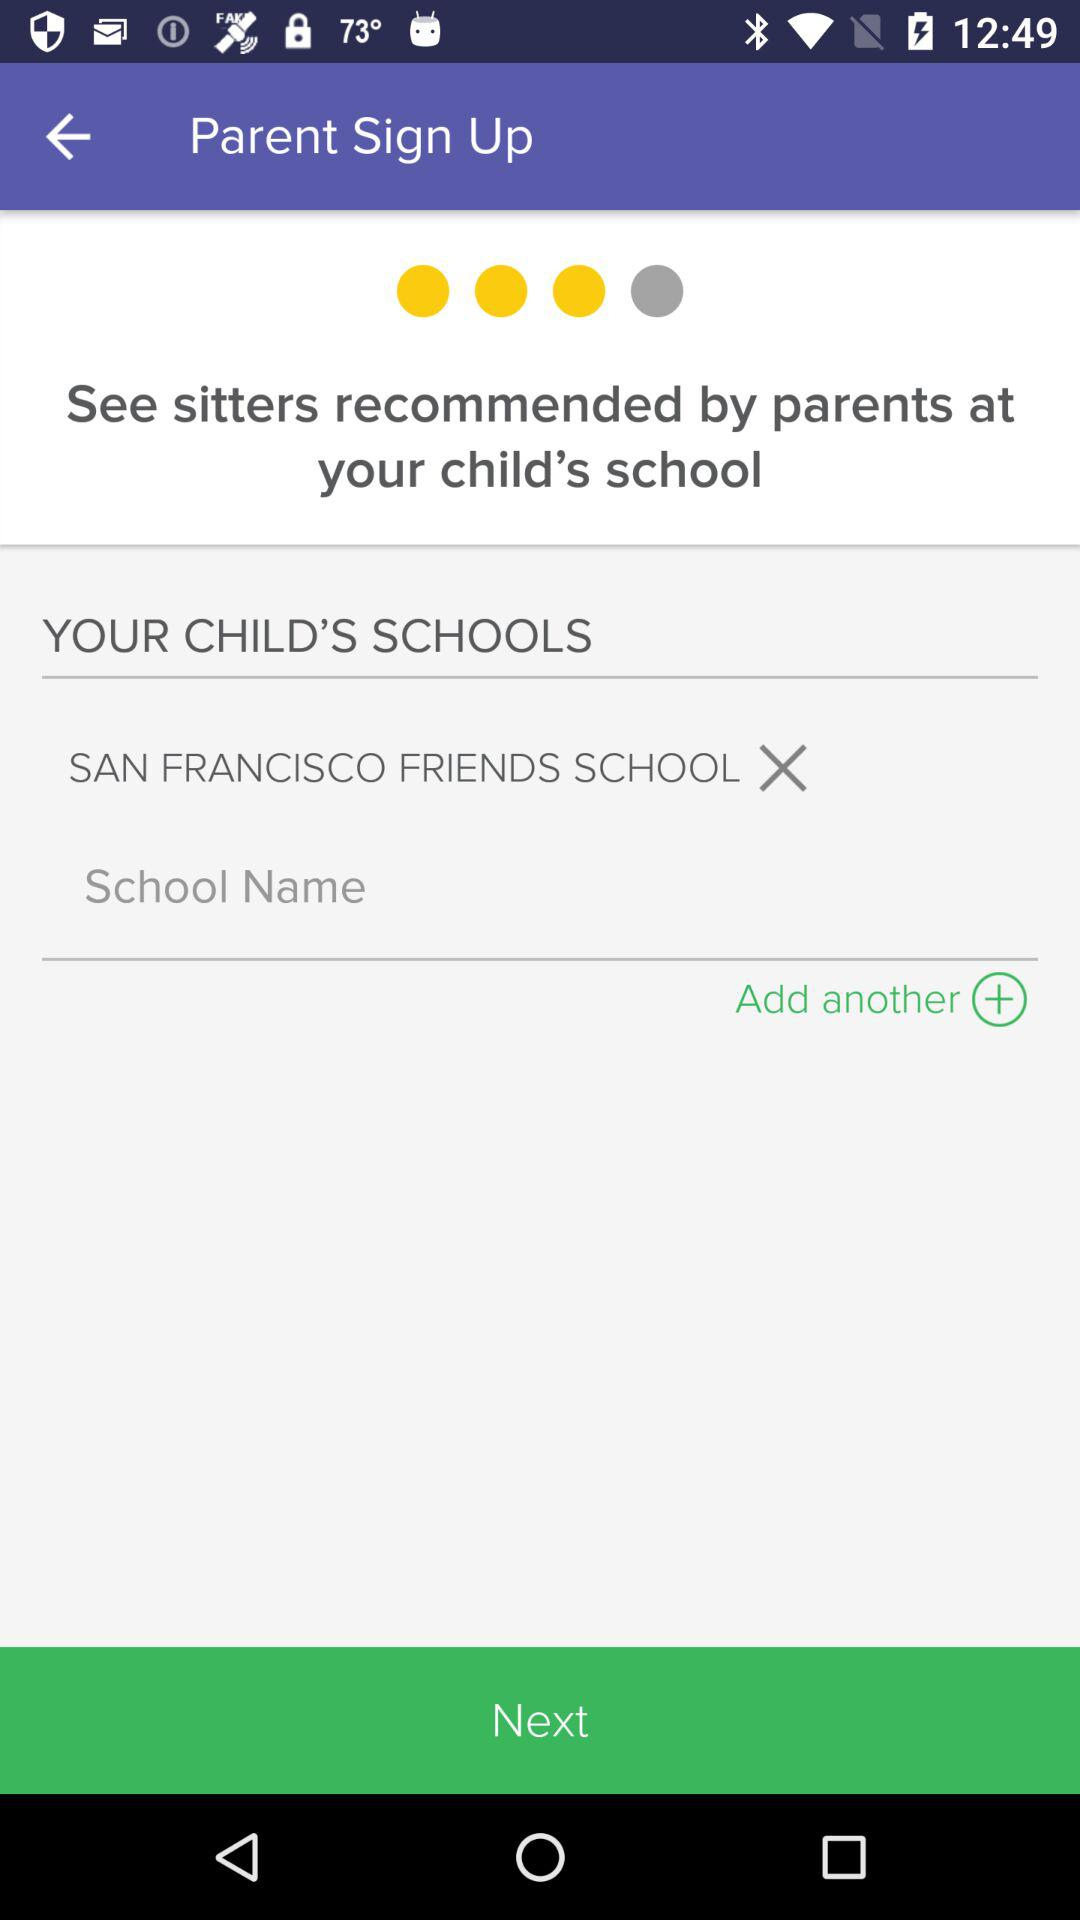What is the school's name? The school's name is SAN FRANCISCO FRIENDS SCHOOL. 